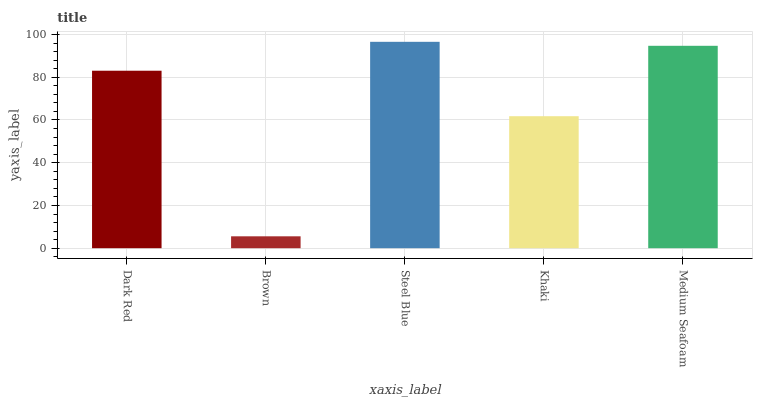Is Brown the minimum?
Answer yes or no. Yes. Is Steel Blue the maximum?
Answer yes or no. Yes. Is Steel Blue the minimum?
Answer yes or no. No. Is Brown the maximum?
Answer yes or no. No. Is Steel Blue greater than Brown?
Answer yes or no. Yes. Is Brown less than Steel Blue?
Answer yes or no. Yes. Is Brown greater than Steel Blue?
Answer yes or no. No. Is Steel Blue less than Brown?
Answer yes or no. No. Is Dark Red the high median?
Answer yes or no. Yes. Is Dark Red the low median?
Answer yes or no. Yes. Is Steel Blue the high median?
Answer yes or no. No. Is Brown the low median?
Answer yes or no. No. 